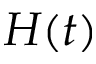<formula> <loc_0><loc_0><loc_500><loc_500>H ( t )</formula> 